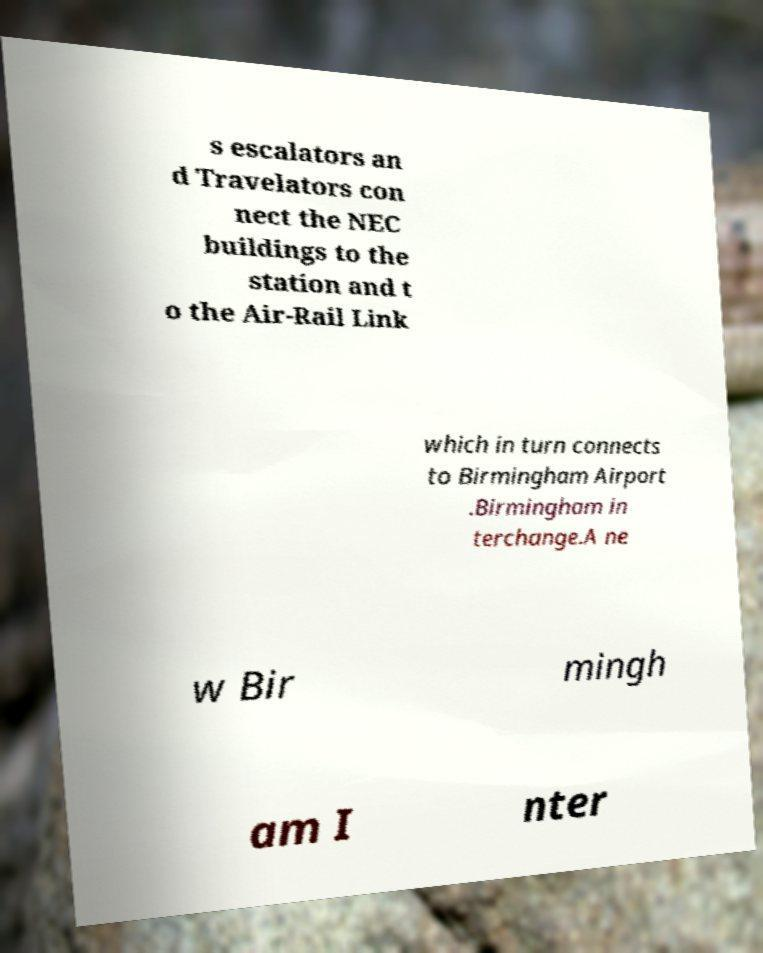Please identify and transcribe the text found in this image. s escalators an d Travelators con nect the NEC buildings to the station and t o the Air-Rail Link which in turn connects to Birmingham Airport .Birmingham in terchange.A ne w Bir mingh am I nter 